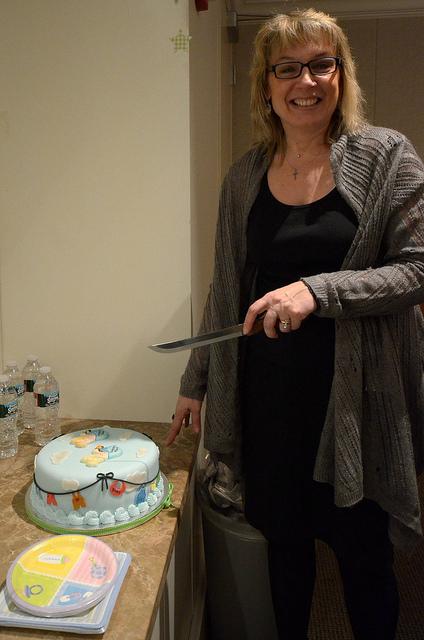What color is this girl's hair?
Concise answer only. Blonde. What kind of celebration is this?
Concise answer only. Baby shower. What does the woman have on her hands?
Be succinct. Knife. Is the woman looking at the camera?
Write a very short answer. Yes. How many people are cutting the cake?
Write a very short answer. 1. Does this food make your eyes water?
Be succinct. No. Are there multiple utensils in the photo?
Give a very brief answer. No. How many cakes are on the table?
Concise answer only. 1. What is the woman doing?
Keep it brief. Cutting cake. Is this a Christmas cake?
Short answer required. No. What flavor of frosting is on the cake?
Concise answer only. Vanilla. Is this a homemade cake?
Keep it brief. No. What does it say on the cake?
Answer briefly. Nothing. Is this a job?
Write a very short answer. No. What kind of food is this?
Answer briefly. Cake. What is the origin of this food?
Give a very brief answer. Cake. What is she cutting?
Short answer required. Cake. What color hair does the woman in the red shirt have?
Be succinct. Blonde. Is the woman looking at the camera or the cake?
Short answer required. Camera. 